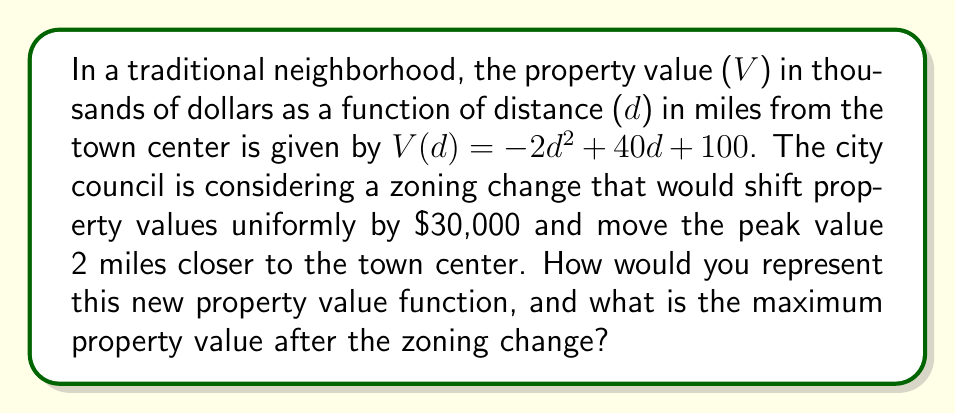Provide a solution to this math problem. 1. The original function is $V(d) = -2d^2 + 40d + 100$.

2. To shift property values uniformly by $30,000, we add 30 to the function (since the function is in thousands of dollars):
   $V_1(d) = -2d^2 + 40d + 100 + 30 = -2d^2 + 40d + 130$

3. To move the peak value 2 miles closer to the town center, we replace d with (d+2):
   $V_2(d) = -2(d+2)^2 + 40(d+2) + 130$

4. Expand the squared term:
   $V_2(d) = -2(d^2 + 4d + 4) + 40d + 80 + 130$
   $V_2(d) = -2d^2 - 8d - 8 + 40d + 210$
   $V_2(d) = -2d^2 + 32d + 202$

5. This is the new property value function after the zoning change.

6. To find the maximum value, we need to find the vertex of this parabola:
   The x-coordinate of the vertex is given by $-b/(2a)$ where $a=-2$ and $b=32$
   $d_{max} = -32/(-4) = 8$

7. Plug this back into the function:
   $V_2(8) = -2(8)^2 + 32(8) + 202$
   $V_2(8) = -128 + 256 + 202 = 330$

The maximum property value after the zoning change is $330,000.
Answer: $V_2(d) = -2d^2 + 32d + 202$; $330,000 